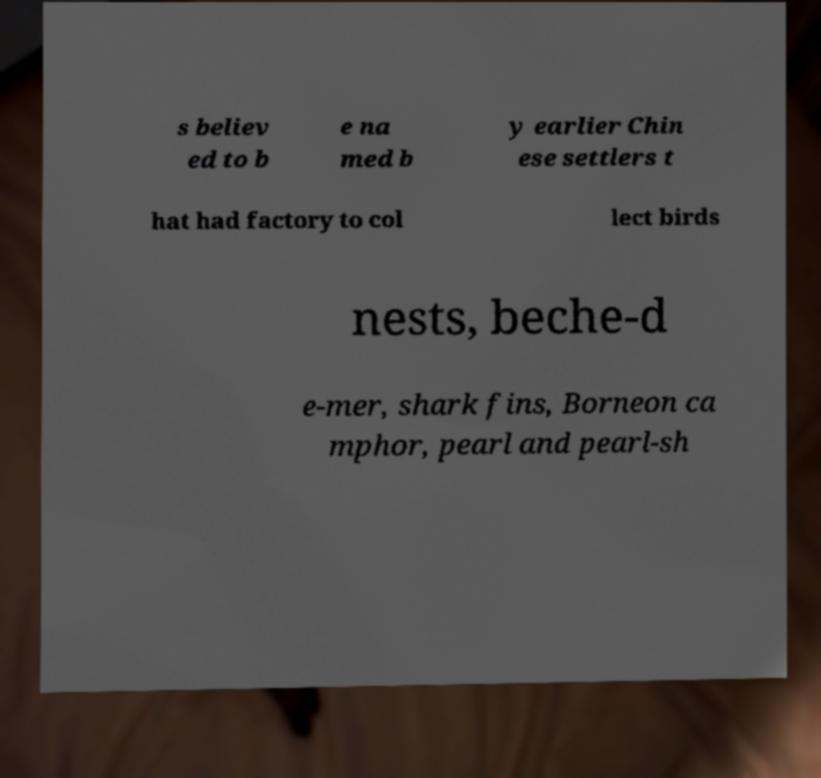Could you assist in decoding the text presented in this image and type it out clearly? s believ ed to b e na med b y earlier Chin ese settlers t hat had factory to col lect birds nests, beche-d e-mer, shark fins, Borneon ca mphor, pearl and pearl-sh 